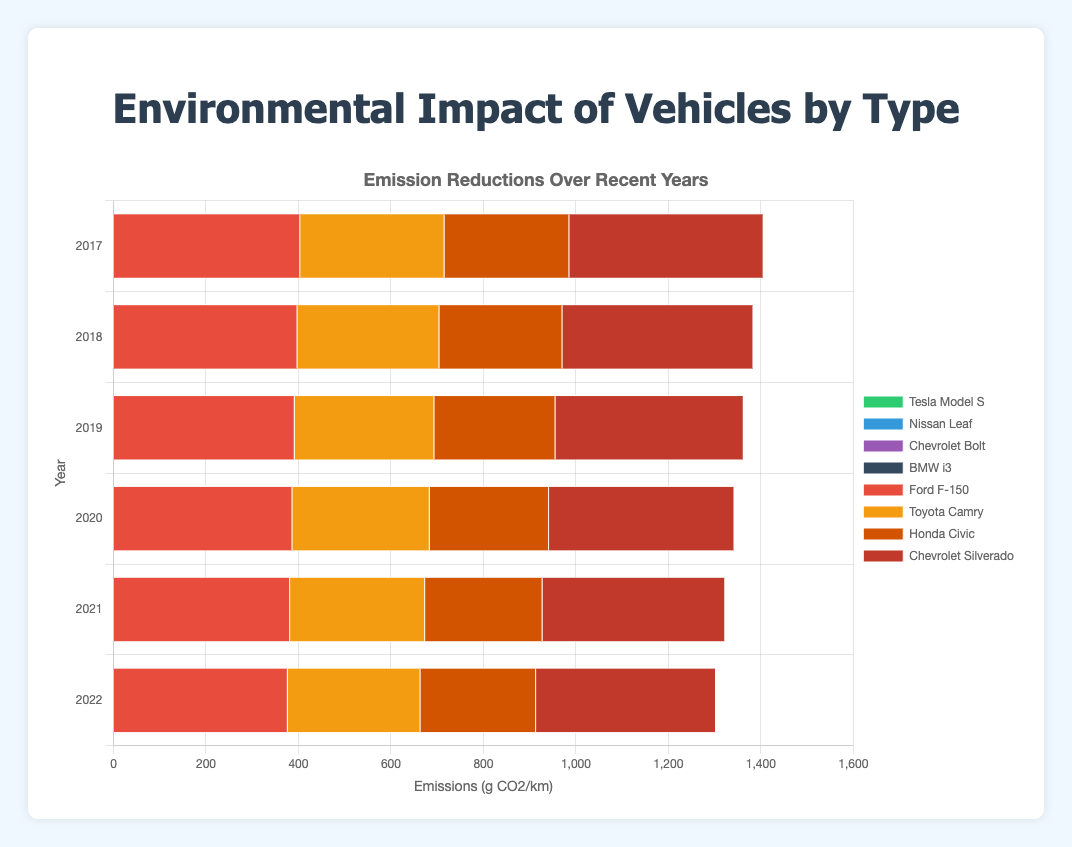What is the emission reduction in g CO2/km for the Ford F-150 from 2017 to 2022? The emissions in 2017 are 404 g CO2/km, and in 2022 they are 377 g CO2/km. The reduction is calculated as 404 - 377.
Answer: 27 Which vehicle type shows zero emissions throughout all years on the chart? Observing the chart, Electric Vehicles like Tesla Model S, Nissan Leaf, Chevrolet Bolt, and BMW i3 all show zero emissions for each year.
Answer: Electric Vehicles In 2021, which traditional vehicle has the highest emissions? In 2021, the emissions for traditional vehicles are: Ford F-150 (382), Toyota Camry (292), Honda Civic (254), and Chevrolet Silverado (395). The highest value is for Chevrolet Silverado.
Answer: Chevrolet Silverado What is the average emission of the Toyota Camry across the years 2017-2022? The emissions are 312, 307, 302, 297, 292, and 287 g CO2/km for each year respectively. Average is calculated as (312 + 307 + 302 + 297 + 292 + 287) / 6.
Answer: 299.5 Compare the emission reduction between the Honda Civic and Chevrolet Silverado from 2017 to 2022. Which had a greater reduction? For the Honda Civic: 270 - 250 = 20. For the Chevrolet Silverado: 420 - 389 = 31.
Answer: Chevrolet Silverado Which vehicle shows the lowest emissions in the year 2020 among traditional vehicles? Emissions in 2020 for traditional vehicles are: Ford F-150 (387), Toyota Camry (297), Honda Civic (258), and Chevrolet Silverado (401). The lowest is for Honda Civic.
Answer: Honda Civic How does the emission trend of the Ford F-150 differ from that of the Toyota Camry from 2017 to 2022? The Ford F-150 shows a consistent linear decrease from 404 to 377, while the Toyota Camry shows a similar trend but with a lower starting point (312 to 287). Both decrease, but the Ford F-150 has a higher initial value and greater drop.
Answer: Both decrease, Ford F-150 has a higher initial emission and greater drop What is the sum of emissions of all traditional vehicles in 2019? Emissions in 2019 for traditional vehicles are: Ford F-150 (392), Toyota Camry (302), Honda Civic (262), Chevrolet Silverado (407). Their sum is 392 + 302 + 262 + 407.
Answer: 1363 Which vehicle, Tesla Model S or Ford F-150, shows any change in emissions over the years? Tesla Model S has consistently zero emissions, while the Ford F-150 shows a decreasing trend from 404 to 377.
Answer: Ford F-150 